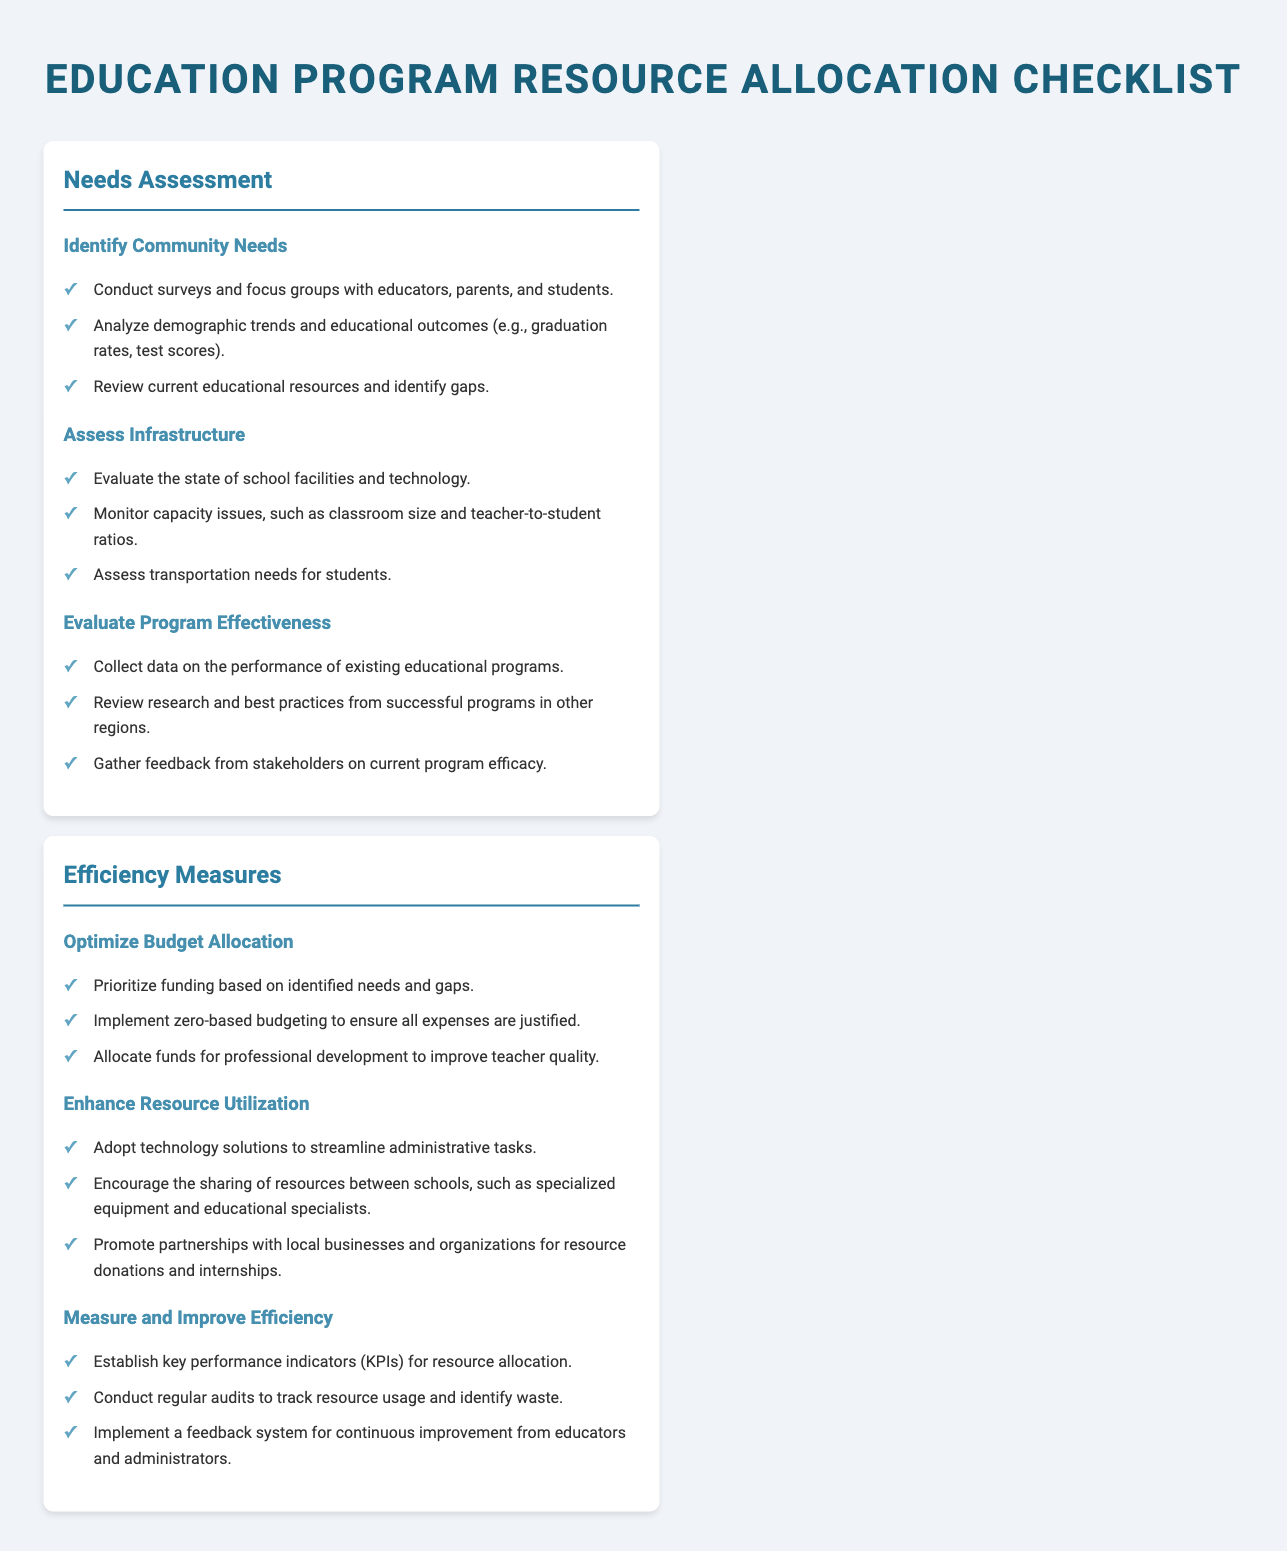What is the title of the document? The title of the document appears at the top and indicates the main subject of the content, which is resource allocation in education programs.
Answer: Education Program Resource Allocation Checklist How many sections are in the document? The document is divided into two main sections that focus on different aspects of education program resource allocation.
Answer: 2 What is one method suggested for identifying community needs? The document outlines several methods, including the use of surveys and focus groups to gather input from key stakeholders in the community.
Answer: Conduct surveys and focus groups with educators, parents, and students What key performance measure is suggested for improving efficiency? The document mentions the establishment of specific indicators to assess how well resources are being allocated and utilized.
Answer: Key performance indicators (KPIs) What is recommended for optimizing budget allocation? The document provides guidance on budget management, emphasizing the importance of prioritizing expenditures based on community needs.
Answer: Prioritize funding based on identified needs and gaps Which section contains measures for enhancing resource utilization? Each section is labeled clearly, allowing readers to identify where particular measures and strategies can be found within the document.
Answer: Efficiency Measures 